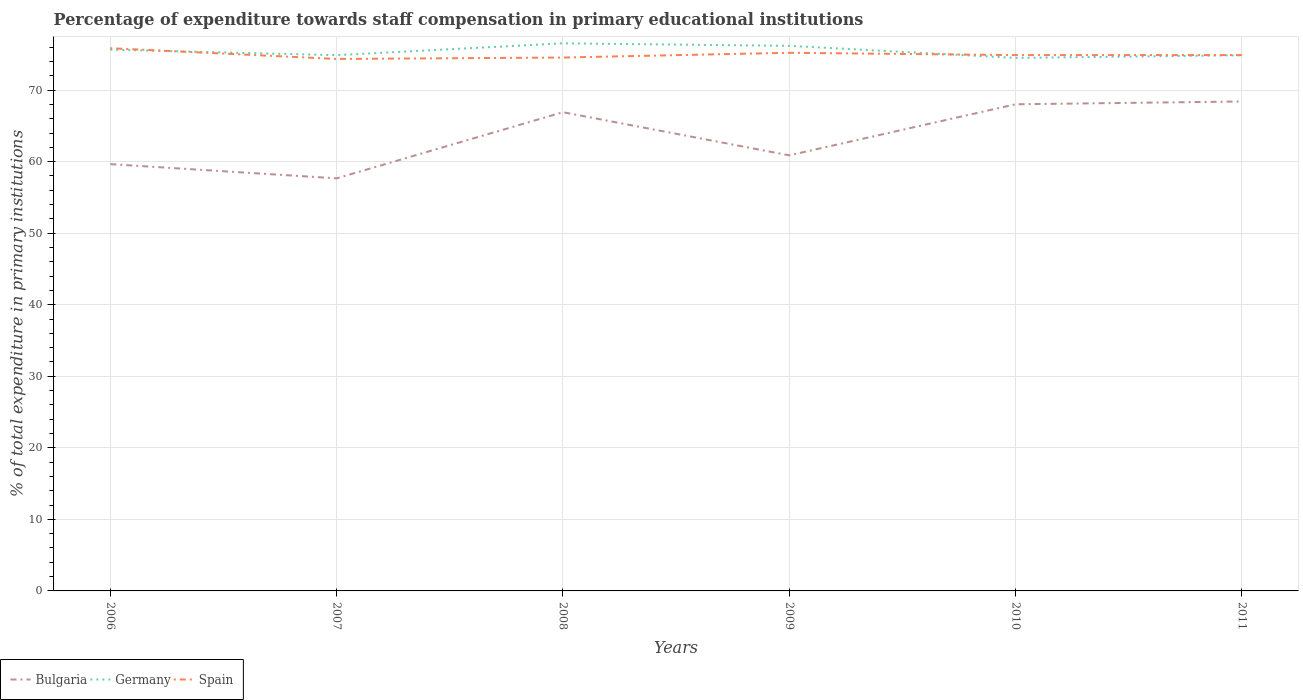Does the line corresponding to Bulgaria intersect with the line corresponding to Spain?
Provide a short and direct response. No. Is the number of lines equal to the number of legend labels?
Offer a very short reply. Yes. Across all years, what is the maximum percentage of expenditure towards staff compensation in Bulgaria?
Offer a terse response. 57.67. In which year was the percentage of expenditure towards staff compensation in Bulgaria maximum?
Your answer should be very brief. 2007. What is the total percentage of expenditure towards staff compensation in Germany in the graph?
Give a very brief answer. -0.37. What is the difference between the highest and the second highest percentage of expenditure towards staff compensation in Spain?
Provide a succinct answer. 1.51. What is the difference between the highest and the lowest percentage of expenditure towards staff compensation in Germany?
Your answer should be compact. 3. Is the percentage of expenditure towards staff compensation in Spain strictly greater than the percentage of expenditure towards staff compensation in Bulgaria over the years?
Your response must be concise. No. How many lines are there?
Ensure brevity in your answer.  3. Does the graph contain grids?
Provide a short and direct response. Yes. Where does the legend appear in the graph?
Keep it short and to the point. Bottom left. How many legend labels are there?
Keep it short and to the point. 3. What is the title of the graph?
Keep it short and to the point. Percentage of expenditure towards staff compensation in primary educational institutions. Does "United Arab Emirates" appear as one of the legend labels in the graph?
Offer a terse response. No. What is the label or title of the Y-axis?
Offer a terse response. % of total expenditure in primary institutions. What is the % of total expenditure in primary institutions in Bulgaria in 2006?
Your response must be concise. 59.65. What is the % of total expenditure in primary institutions in Germany in 2006?
Your response must be concise. 75.65. What is the % of total expenditure in primary institutions of Spain in 2006?
Offer a very short reply. 75.86. What is the % of total expenditure in primary institutions in Bulgaria in 2007?
Ensure brevity in your answer.  57.67. What is the % of total expenditure in primary institutions of Germany in 2007?
Your response must be concise. 74.88. What is the % of total expenditure in primary institutions of Spain in 2007?
Offer a very short reply. 74.35. What is the % of total expenditure in primary institutions of Bulgaria in 2008?
Ensure brevity in your answer.  66.91. What is the % of total expenditure in primary institutions of Germany in 2008?
Offer a very short reply. 76.54. What is the % of total expenditure in primary institutions in Spain in 2008?
Your answer should be compact. 74.55. What is the % of total expenditure in primary institutions in Bulgaria in 2009?
Ensure brevity in your answer.  60.88. What is the % of total expenditure in primary institutions in Germany in 2009?
Your response must be concise. 76.19. What is the % of total expenditure in primary institutions in Spain in 2009?
Provide a short and direct response. 75.22. What is the % of total expenditure in primary institutions of Bulgaria in 2010?
Give a very brief answer. 68.02. What is the % of total expenditure in primary institutions in Germany in 2010?
Give a very brief answer. 74.5. What is the % of total expenditure in primary institutions in Spain in 2010?
Keep it short and to the point. 74.89. What is the % of total expenditure in primary institutions of Bulgaria in 2011?
Provide a short and direct response. 68.41. What is the % of total expenditure in primary institutions in Germany in 2011?
Offer a terse response. 74.87. What is the % of total expenditure in primary institutions in Spain in 2011?
Your answer should be very brief. 74.89. Across all years, what is the maximum % of total expenditure in primary institutions in Bulgaria?
Your answer should be very brief. 68.41. Across all years, what is the maximum % of total expenditure in primary institutions in Germany?
Your response must be concise. 76.54. Across all years, what is the maximum % of total expenditure in primary institutions of Spain?
Your answer should be very brief. 75.86. Across all years, what is the minimum % of total expenditure in primary institutions of Bulgaria?
Give a very brief answer. 57.67. Across all years, what is the minimum % of total expenditure in primary institutions in Germany?
Ensure brevity in your answer.  74.5. Across all years, what is the minimum % of total expenditure in primary institutions in Spain?
Your answer should be compact. 74.35. What is the total % of total expenditure in primary institutions in Bulgaria in the graph?
Give a very brief answer. 381.54. What is the total % of total expenditure in primary institutions of Germany in the graph?
Your answer should be compact. 452.64. What is the total % of total expenditure in primary institutions of Spain in the graph?
Give a very brief answer. 449.77. What is the difference between the % of total expenditure in primary institutions in Bulgaria in 2006 and that in 2007?
Offer a terse response. 1.99. What is the difference between the % of total expenditure in primary institutions in Germany in 2006 and that in 2007?
Keep it short and to the point. 0.77. What is the difference between the % of total expenditure in primary institutions of Spain in 2006 and that in 2007?
Ensure brevity in your answer.  1.51. What is the difference between the % of total expenditure in primary institutions of Bulgaria in 2006 and that in 2008?
Ensure brevity in your answer.  -7.26. What is the difference between the % of total expenditure in primary institutions in Germany in 2006 and that in 2008?
Make the answer very short. -0.89. What is the difference between the % of total expenditure in primary institutions in Spain in 2006 and that in 2008?
Keep it short and to the point. 1.31. What is the difference between the % of total expenditure in primary institutions of Bulgaria in 2006 and that in 2009?
Your answer should be very brief. -1.23. What is the difference between the % of total expenditure in primary institutions of Germany in 2006 and that in 2009?
Provide a succinct answer. -0.53. What is the difference between the % of total expenditure in primary institutions of Spain in 2006 and that in 2009?
Offer a terse response. 0.64. What is the difference between the % of total expenditure in primary institutions in Bulgaria in 2006 and that in 2010?
Provide a short and direct response. -8.37. What is the difference between the % of total expenditure in primary institutions in Germany in 2006 and that in 2010?
Make the answer very short. 1.15. What is the difference between the % of total expenditure in primary institutions of Spain in 2006 and that in 2010?
Offer a terse response. 0.97. What is the difference between the % of total expenditure in primary institutions in Bulgaria in 2006 and that in 2011?
Your answer should be very brief. -8.76. What is the difference between the % of total expenditure in primary institutions of Germany in 2006 and that in 2011?
Offer a very short reply. 0.78. What is the difference between the % of total expenditure in primary institutions in Spain in 2006 and that in 2011?
Your response must be concise. 0.97. What is the difference between the % of total expenditure in primary institutions in Bulgaria in 2007 and that in 2008?
Your response must be concise. -9.25. What is the difference between the % of total expenditure in primary institutions in Germany in 2007 and that in 2008?
Provide a short and direct response. -1.65. What is the difference between the % of total expenditure in primary institutions in Spain in 2007 and that in 2008?
Make the answer very short. -0.2. What is the difference between the % of total expenditure in primary institutions in Bulgaria in 2007 and that in 2009?
Offer a very short reply. -3.22. What is the difference between the % of total expenditure in primary institutions in Germany in 2007 and that in 2009?
Provide a succinct answer. -1.3. What is the difference between the % of total expenditure in primary institutions of Spain in 2007 and that in 2009?
Your answer should be compact. -0.86. What is the difference between the % of total expenditure in primary institutions of Bulgaria in 2007 and that in 2010?
Your response must be concise. -10.35. What is the difference between the % of total expenditure in primary institutions in Germany in 2007 and that in 2010?
Give a very brief answer. 0.38. What is the difference between the % of total expenditure in primary institutions of Spain in 2007 and that in 2010?
Offer a terse response. -0.54. What is the difference between the % of total expenditure in primary institutions in Bulgaria in 2007 and that in 2011?
Offer a terse response. -10.74. What is the difference between the % of total expenditure in primary institutions of Germany in 2007 and that in 2011?
Ensure brevity in your answer.  0.01. What is the difference between the % of total expenditure in primary institutions in Spain in 2007 and that in 2011?
Offer a terse response. -0.54. What is the difference between the % of total expenditure in primary institutions in Bulgaria in 2008 and that in 2009?
Keep it short and to the point. 6.03. What is the difference between the % of total expenditure in primary institutions in Germany in 2008 and that in 2009?
Offer a terse response. 0.35. What is the difference between the % of total expenditure in primary institutions of Spain in 2008 and that in 2009?
Ensure brevity in your answer.  -0.66. What is the difference between the % of total expenditure in primary institutions in Bulgaria in 2008 and that in 2010?
Your answer should be compact. -1.11. What is the difference between the % of total expenditure in primary institutions in Germany in 2008 and that in 2010?
Your response must be concise. 2.04. What is the difference between the % of total expenditure in primary institutions of Spain in 2008 and that in 2010?
Your answer should be very brief. -0.34. What is the difference between the % of total expenditure in primary institutions in Bulgaria in 2008 and that in 2011?
Your answer should be very brief. -1.5. What is the difference between the % of total expenditure in primary institutions of Germany in 2008 and that in 2011?
Keep it short and to the point. 1.67. What is the difference between the % of total expenditure in primary institutions in Spain in 2008 and that in 2011?
Provide a short and direct response. -0.34. What is the difference between the % of total expenditure in primary institutions of Bulgaria in 2009 and that in 2010?
Provide a short and direct response. -7.14. What is the difference between the % of total expenditure in primary institutions of Germany in 2009 and that in 2010?
Your response must be concise. 1.69. What is the difference between the % of total expenditure in primary institutions in Spain in 2009 and that in 2010?
Provide a succinct answer. 0.32. What is the difference between the % of total expenditure in primary institutions in Bulgaria in 2009 and that in 2011?
Make the answer very short. -7.53. What is the difference between the % of total expenditure in primary institutions of Germany in 2009 and that in 2011?
Your answer should be very brief. 1.32. What is the difference between the % of total expenditure in primary institutions in Spain in 2009 and that in 2011?
Make the answer very short. 0.32. What is the difference between the % of total expenditure in primary institutions of Bulgaria in 2010 and that in 2011?
Your response must be concise. -0.39. What is the difference between the % of total expenditure in primary institutions in Germany in 2010 and that in 2011?
Offer a terse response. -0.37. What is the difference between the % of total expenditure in primary institutions of Bulgaria in 2006 and the % of total expenditure in primary institutions of Germany in 2007?
Keep it short and to the point. -15.23. What is the difference between the % of total expenditure in primary institutions in Bulgaria in 2006 and the % of total expenditure in primary institutions in Spain in 2007?
Your answer should be compact. -14.7. What is the difference between the % of total expenditure in primary institutions in Germany in 2006 and the % of total expenditure in primary institutions in Spain in 2007?
Give a very brief answer. 1.3. What is the difference between the % of total expenditure in primary institutions of Bulgaria in 2006 and the % of total expenditure in primary institutions of Germany in 2008?
Your response must be concise. -16.89. What is the difference between the % of total expenditure in primary institutions in Bulgaria in 2006 and the % of total expenditure in primary institutions in Spain in 2008?
Your answer should be compact. -14.9. What is the difference between the % of total expenditure in primary institutions of Germany in 2006 and the % of total expenditure in primary institutions of Spain in 2008?
Keep it short and to the point. 1.1. What is the difference between the % of total expenditure in primary institutions of Bulgaria in 2006 and the % of total expenditure in primary institutions of Germany in 2009?
Your answer should be very brief. -16.54. What is the difference between the % of total expenditure in primary institutions in Bulgaria in 2006 and the % of total expenditure in primary institutions in Spain in 2009?
Make the answer very short. -15.56. What is the difference between the % of total expenditure in primary institutions in Germany in 2006 and the % of total expenditure in primary institutions in Spain in 2009?
Make the answer very short. 0.44. What is the difference between the % of total expenditure in primary institutions of Bulgaria in 2006 and the % of total expenditure in primary institutions of Germany in 2010?
Offer a very short reply. -14.85. What is the difference between the % of total expenditure in primary institutions in Bulgaria in 2006 and the % of total expenditure in primary institutions in Spain in 2010?
Offer a terse response. -15.24. What is the difference between the % of total expenditure in primary institutions of Germany in 2006 and the % of total expenditure in primary institutions of Spain in 2010?
Offer a terse response. 0.76. What is the difference between the % of total expenditure in primary institutions in Bulgaria in 2006 and the % of total expenditure in primary institutions in Germany in 2011?
Keep it short and to the point. -15.22. What is the difference between the % of total expenditure in primary institutions in Bulgaria in 2006 and the % of total expenditure in primary institutions in Spain in 2011?
Offer a very short reply. -15.24. What is the difference between the % of total expenditure in primary institutions of Germany in 2006 and the % of total expenditure in primary institutions of Spain in 2011?
Ensure brevity in your answer.  0.76. What is the difference between the % of total expenditure in primary institutions of Bulgaria in 2007 and the % of total expenditure in primary institutions of Germany in 2008?
Your response must be concise. -18.87. What is the difference between the % of total expenditure in primary institutions of Bulgaria in 2007 and the % of total expenditure in primary institutions of Spain in 2008?
Give a very brief answer. -16.89. What is the difference between the % of total expenditure in primary institutions of Germany in 2007 and the % of total expenditure in primary institutions of Spain in 2008?
Offer a terse response. 0.33. What is the difference between the % of total expenditure in primary institutions of Bulgaria in 2007 and the % of total expenditure in primary institutions of Germany in 2009?
Give a very brief answer. -18.52. What is the difference between the % of total expenditure in primary institutions of Bulgaria in 2007 and the % of total expenditure in primary institutions of Spain in 2009?
Your answer should be compact. -17.55. What is the difference between the % of total expenditure in primary institutions in Germany in 2007 and the % of total expenditure in primary institutions in Spain in 2009?
Keep it short and to the point. -0.33. What is the difference between the % of total expenditure in primary institutions of Bulgaria in 2007 and the % of total expenditure in primary institutions of Germany in 2010?
Offer a very short reply. -16.84. What is the difference between the % of total expenditure in primary institutions of Bulgaria in 2007 and the % of total expenditure in primary institutions of Spain in 2010?
Make the answer very short. -17.23. What is the difference between the % of total expenditure in primary institutions in Germany in 2007 and the % of total expenditure in primary institutions in Spain in 2010?
Keep it short and to the point. -0.01. What is the difference between the % of total expenditure in primary institutions of Bulgaria in 2007 and the % of total expenditure in primary institutions of Germany in 2011?
Provide a short and direct response. -17.21. What is the difference between the % of total expenditure in primary institutions in Bulgaria in 2007 and the % of total expenditure in primary institutions in Spain in 2011?
Give a very brief answer. -17.23. What is the difference between the % of total expenditure in primary institutions of Germany in 2007 and the % of total expenditure in primary institutions of Spain in 2011?
Provide a short and direct response. -0.01. What is the difference between the % of total expenditure in primary institutions of Bulgaria in 2008 and the % of total expenditure in primary institutions of Germany in 2009?
Ensure brevity in your answer.  -9.28. What is the difference between the % of total expenditure in primary institutions of Bulgaria in 2008 and the % of total expenditure in primary institutions of Spain in 2009?
Ensure brevity in your answer.  -8.3. What is the difference between the % of total expenditure in primary institutions in Germany in 2008 and the % of total expenditure in primary institutions in Spain in 2009?
Provide a short and direct response. 1.32. What is the difference between the % of total expenditure in primary institutions of Bulgaria in 2008 and the % of total expenditure in primary institutions of Germany in 2010?
Keep it short and to the point. -7.59. What is the difference between the % of total expenditure in primary institutions in Bulgaria in 2008 and the % of total expenditure in primary institutions in Spain in 2010?
Give a very brief answer. -7.98. What is the difference between the % of total expenditure in primary institutions in Germany in 2008 and the % of total expenditure in primary institutions in Spain in 2010?
Ensure brevity in your answer.  1.65. What is the difference between the % of total expenditure in primary institutions of Bulgaria in 2008 and the % of total expenditure in primary institutions of Germany in 2011?
Keep it short and to the point. -7.96. What is the difference between the % of total expenditure in primary institutions in Bulgaria in 2008 and the % of total expenditure in primary institutions in Spain in 2011?
Provide a succinct answer. -7.98. What is the difference between the % of total expenditure in primary institutions in Germany in 2008 and the % of total expenditure in primary institutions in Spain in 2011?
Give a very brief answer. 1.65. What is the difference between the % of total expenditure in primary institutions in Bulgaria in 2009 and the % of total expenditure in primary institutions in Germany in 2010?
Offer a very short reply. -13.62. What is the difference between the % of total expenditure in primary institutions in Bulgaria in 2009 and the % of total expenditure in primary institutions in Spain in 2010?
Give a very brief answer. -14.01. What is the difference between the % of total expenditure in primary institutions of Germany in 2009 and the % of total expenditure in primary institutions of Spain in 2010?
Offer a terse response. 1.29. What is the difference between the % of total expenditure in primary institutions in Bulgaria in 2009 and the % of total expenditure in primary institutions in Germany in 2011?
Provide a short and direct response. -13.99. What is the difference between the % of total expenditure in primary institutions in Bulgaria in 2009 and the % of total expenditure in primary institutions in Spain in 2011?
Your answer should be very brief. -14.01. What is the difference between the % of total expenditure in primary institutions in Germany in 2009 and the % of total expenditure in primary institutions in Spain in 2011?
Provide a succinct answer. 1.29. What is the difference between the % of total expenditure in primary institutions in Bulgaria in 2010 and the % of total expenditure in primary institutions in Germany in 2011?
Provide a short and direct response. -6.85. What is the difference between the % of total expenditure in primary institutions in Bulgaria in 2010 and the % of total expenditure in primary institutions in Spain in 2011?
Offer a terse response. -6.87. What is the difference between the % of total expenditure in primary institutions of Germany in 2010 and the % of total expenditure in primary institutions of Spain in 2011?
Your answer should be very brief. -0.39. What is the average % of total expenditure in primary institutions of Bulgaria per year?
Provide a short and direct response. 63.59. What is the average % of total expenditure in primary institutions of Germany per year?
Provide a succinct answer. 75.44. What is the average % of total expenditure in primary institutions in Spain per year?
Your response must be concise. 74.96. In the year 2006, what is the difference between the % of total expenditure in primary institutions of Bulgaria and % of total expenditure in primary institutions of Germany?
Your response must be concise. -16. In the year 2006, what is the difference between the % of total expenditure in primary institutions in Bulgaria and % of total expenditure in primary institutions in Spain?
Offer a very short reply. -16.21. In the year 2006, what is the difference between the % of total expenditure in primary institutions in Germany and % of total expenditure in primary institutions in Spain?
Make the answer very short. -0.21. In the year 2007, what is the difference between the % of total expenditure in primary institutions in Bulgaria and % of total expenditure in primary institutions in Germany?
Your response must be concise. -17.22. In the year 2007, what is the difference between the % of total expenditure in primary institutions in Bulgaria and % of total expenditure in primary institutions in Spain?
Give a very brief answer. -16.69. In the year 2007, what is the difference between the % of total expenditure in primary institutions of Germany and % of total expenditure in primary institutions of Spain?
Your answer should be very brief. 0.53. In the year 2008, what is the difference between the % of total expenditure in primary institutions of Bulgaria and % of total expenditure in primary institutions of Germany?
Your response must be concise. -9.63. In the year 2008, what is the difference between the % of total expenditure in primary institutions of Bulgaria and % of total expenditure in primary institutions of Spain?
Keep it short and to the point. -7.64. In the year 2008, what is the difference between the % of total expenditure in primary institutions in Germany and % of total expenditure in primary institutions in Spain?
Your response must be concise. 1.99. In the year 2009, what is the difference between the % of total expenditure in primary institutions in Bulgaria and % of total expenditure in primary institutions in Germany?
Give a very brief answer. -15.31. In the year 2009, what is the difference between the % of total expenditure in primary institutions of Bulgaria and % of total expenditure in primary institutions of Spain?
Ensure brevity in your answer.  -14.34. In the year 2009, what is the difference between the % of total expenditure in primary institutions in Germany and % of total expenditure in primary institutions in Spain?
Ensure brevity in your answer.  0.97. In the year 2010, what is the difference between the % of total expenditure in primary institutions in Bulgaria and % of total expenditure in primary institutions in Germany?
Offer a terse response. -6.48. In the year 2010, what is the difference between the % of total expenditure in primary institutions in Bulgaria and % of total expenditure in primary institutions in Spain?
Your answer should be very brief. -6.87. In the year 2010, what is the difference between the % of total expenditure in primary institutions of Germany and % of total expenditure in primary institutions of Spain?
Ensure brevity in your answer.  -0.39. In the year 2011, what is the difference between the % of total expenditure in primary institutions of Bulgaria and % of total expenditure in primary institutions of Germany?
Provide a short and direct response. -6.46. In the year 2011, what is the difference between the % of total expenditure in primary institutions in Bulgaria and % of total expenditure in primary institutions in Spain?
Offer a terse response. -6.48. In the year 2011, what is the difference between the % of total expenditure in primary institutions of Germany and % of total expenditure in primary institutions of Spain?
Offer a very short reply. -0.02. What is the ratio of the % of total expenditure in primary institutions of Bulgaria in 2006 to that in 2007?
Your answer should be compact. 1.03. What is the ratio of the % of total expenditure in primary institutions of Germany in 2006 to that in 2007?
Offer a very short reply. 1.01. What is the ratio of the % of total expenditure in primary institutions in Spain in 2006 to that in 2007?
Ensure brevity in your answer.  1.02. What is the ratio of the % of total expenditure in primary institutions in Bulgaria in 2006 to that in 2008?
Give a very brief answer. 0.89. What is the ratio of the % of total expenditure in primary institutions of Germany in 2006 to that in 2008?
Make the answer very short. 0.99. What is the ratio of the % of total expenditure in primary institutions of Spain in 2006 to that in 2008?
Keep it short and to the point. 1.02. What is the ratio of the % of total expenditure in primary institutions in Bulgaria in 2006 to that in 2009?
Your response must be concise. 0.98. What is the ratio of the % of total expenditure in primary institutions of Spain in 2006 to that in 2009?
Offer a very short reply. 1.01. What is the ratio of the % of total expenditure in primary institutions in Bulgaria in 2006 to that in 2010?
Offer a very short reply. 0.88. What is the ratio of the % of total expenditure in primary institutions in Germany in 2006 to that in 2010?
Make the answer very short. 1.02. What is the ratio of the % of total expenditure in primary institutions in Spain in 2006 to that in 2010?
Ensure brevity in your answer.  1.01. What is the ratio of the % of total expenditure in primary institutions of Bulgaria in 2006 to that in 2011?
Your answer should be compact. 0.87. What is the ratio of the % of total expenditure in primary institutions in Germany in 2006 to that in 2011?
Ensure brevity in your answer.  1.01. What is the ratio of the % of total expenditure in primary institutions in Spain in 2006 to that in 2011?
Your response must be concise. 1.01. What is the ratio of the % of total expenditure in primary institutions in Bulgaria in 2007 to that in 2008?
Offer a very short reply. 0.86. What is the ratio of the % of total expenditure in primary institutions in Germany in 2007 to that in 2008?
Ensure brevity in your answer.  0.98. What is the ratio of the % of total expenditure in primary institutions in Spain in 2007 to that in 2008?
Offer a very short reply. 1. What is the ratio of the % of total expenditure in primary institutions in Bulgaria in 2007 to that in 2009?
Provide a short and direct response. 0.95. What is the ratio of the % of total expenditure in primary institutions in Germany in 2007 to that in 2009?
Provide a short and direct response. 0.98. What is the ratio of the % of total expenditure in primary institutions of Spain in 2007 to that in 2009?
Offer a very short reply. 0.99. What is the ratio of the % of total expenditure in primary institutions of Bulgaria in 2007 to that in 2010?
Your answer should be compact. 0.85. What is the ratio of the % of total expenditure in primary institutions of Germany in 2007 to that in 2010?
Make the answer very short. 1.01. What is the ratio of the % of total expenditure in primary institutions of Spain in 2007 to that in 2010?
Ensure brevity in your answer.  0.99. What is the ratio of the % of total expenditure in primary institutions of Bulgaria in 2007 to that in 2011?
Give a very brief answer. 0.84. What is the ratio of the % of total expenditure in primary institutions of Spain in 2007 to that in 2011?
Your answer should be very brief. 0.99. What is the ratio of the % of total expenditure in primary institutions of Bulgaria in 2008 to that in 2009?
Provide a succinct answer. 1.1. What is the ratio of the % of total expenditure in primary institutions in Spain in 2008 to that in 2009?
Keep it short and to the point. 0.99. What is the ratio of the % of total expenditure in primary institutions in Bulgaria in 2008 to that in 2010?
Provide a short and direct response. 0.98. What is the ratio of the % of total expenditure in primary institutions of Germany in 2008 to that in 2010?
Keep it short and to the point. 1.03. What is the ratio of the % of total expenditure in primary institutions of Bulgaria in 2008 to that in 2011?
Your response must be concise. 0.98. What is the ratio of the % of total expenditure in primary institutions in Germany in 2008 to that in 2011?
Your answer should be compact. 1.02. What is the ratio of the % of total expenditure in primary institutions in Spain in 2008 to that in 2011?
Ensure brevity in your answer.  1. What is the ratio of the % of total expenditure in primary institutions in Bulgaria in 2009 to that in 2010?
Ensure brevity in your answer.  0.9. What is the ratio of the % of total expenditure in primary institutions in Germany in 2009 to that in 2010?
Your response must be concise. 1.02. What is the ratio of the % of total expenditure in primary institutions of Bulgaria in 2009 to that in 2011?
Your answer should be very brief. 0.89. What is the ratio of the % of total expenditure in primary institutions in Germany in 2009 to that in 2011?
Ensure brevity in your answer.  1.02. What is the ratio of the % of total expenditure in primary institutions in Spain in 2009 to that in 2011?
Your response must be concise. 1. What is the ratio of the % of total expenditure in primary institutions of Bulgaria in 2010 to that in 2011?
Provide a succinct answer. 0.99. What is the ratio of the % of total expenditure in primary institutions in Germany in 2010 to that in 2011?
Ensure brevity in your answer.  0.99. What is the ratio of the % of total expenditure in primary institutions in Spain in 2010 to that in 2011?
Offer a very short reply. 1. What is the difference between the highest and the second highest % of total expenditure in primary institutions in Bulgaria?
Offer a terse response. 0.39. What is the difference between the highest and the second highest % of total expenditure in primary institutions of Germany?
Your answer should be compact. 0.35. What is the difference between the highest and the second highest % of total expenditure in primary institutions of Spain?
Provide a succinct answer. 0.64. What is the difference between the highest and the lowest % of total expenditure in primary institutions in Bulgaria?
Make the answer very short. 10.74. What is the difference between the highest and the lowest % of total expenditure in primary institutions in Germany?
Your response must be concise. 2.04. What is the difference between the highest and the lowest % of total expenditure in primary institutions in Spain?
Keep it short and to the point. 1.51. 